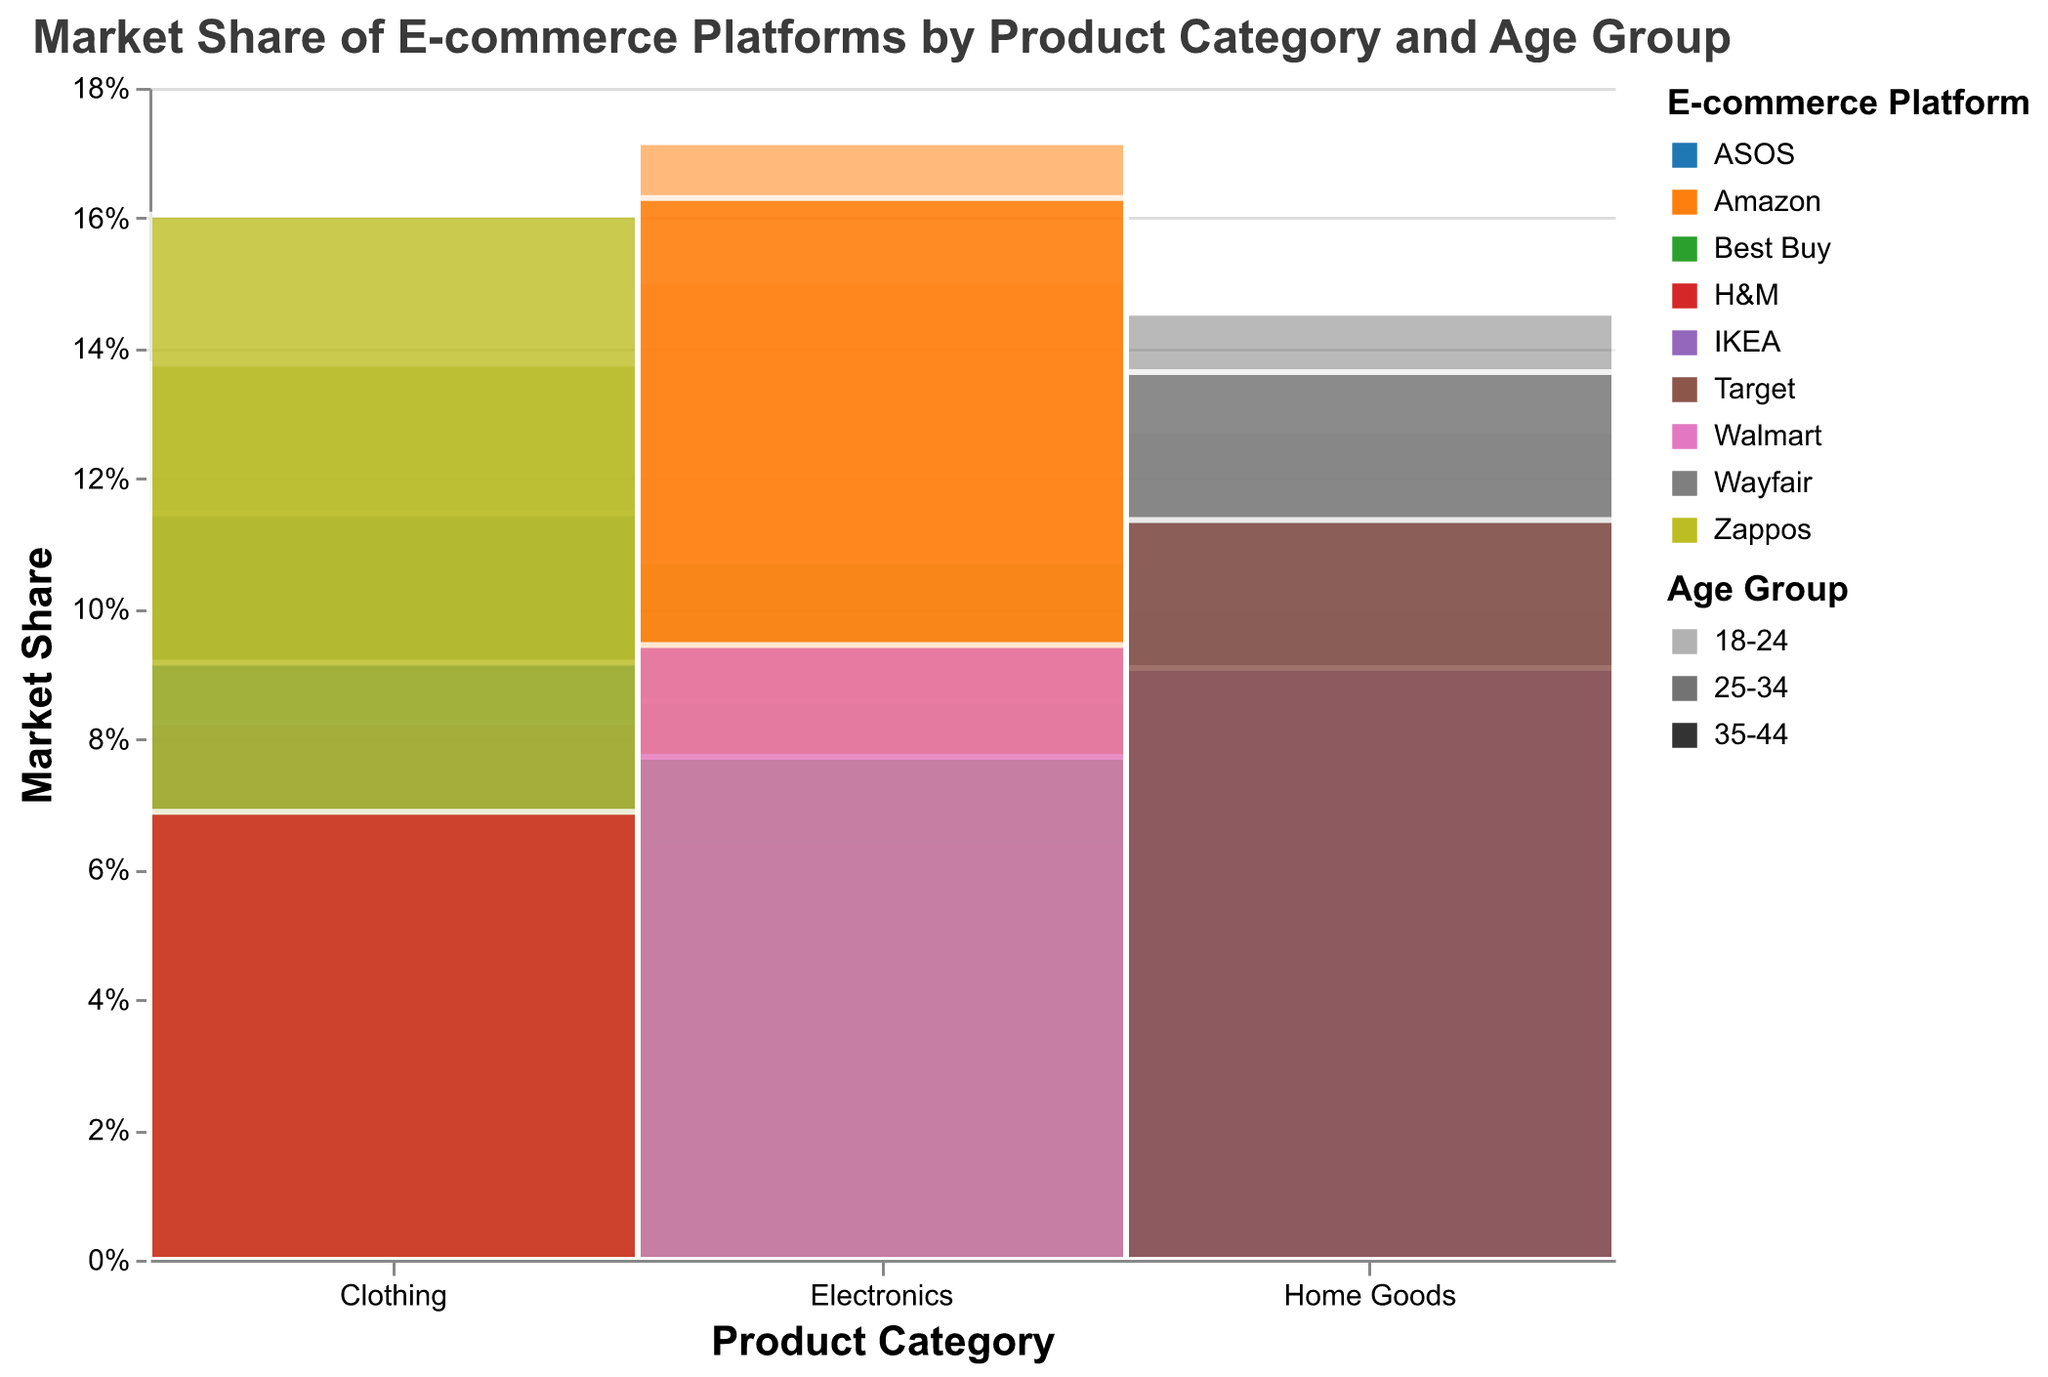What is the title of the figure? The title is the text displayed at the top of the figure indicating what it's about. In this case, it can be found at the center.
Answer: Market Share of E-commerce Platforms by Product Category and Age Group Which e-commerce platform has the highest market share for Electronics in the age group 25-34? To find this, look at the section for Electronics and then focus on the 25-34 age group. The color representing Amazon is the tallest bar in this section.
Answer: Amazon How does the market share of Wayfair for Home Goods compare between the 18-24 and 25-34 age groups? In the Home Goods category, compare the height of the rectangles for Wayfair (color) for both age groups 18-24 and 25-34. Wayfair has a market share of 28 for the 18-24 age group and 32 for the 25-34 age group. Wayfair has a higher market share in the 25-34 age group.
Answer: Wayfair has a higher market share in the 25-34 age group What is the total market share percentage of Best Buy in the Electronics category? Add up the market shares of Best Buy for all age groups in the Electronics category. (25 + 20 + 18) Add this sum and then divide by the sum of the total market share of all platforms in the Electronics category. It involves multiple steps by adding market shares first and then the percentage calculation.
Answer: 20.3% Which platform has the lowest market share for Clothing in the 35-44 age group? In the Clothing category for the 35-44 age group, find the smallest bar. The bar color corresponding to H&M is the smallest.
Answer: H&M In the Home Goods category, which age group has the largest market share for IKEA? Look at the rectangles for IKEA (color coded) in the Home Goods category and compare their sizes across age groups 18-24, 25-34, and 35-44. The largest rectangle for IKEA is in the 25-34 age group.
Answer: 25-34 What product category does Amazon dominate in terms of market share for the 35-44 age group? Look at the product categories and ages where Amazon's color (typically dark) has the largest market share rectangle. For the 35-44 age group, Amazon's largest presence is in the Electronics category.
Answer: Electronics Considering all the platforms, which age group has the highest overall market share in the Clothing category? Sum the market shares for all platforms within each age group in the Clothing category and compare. The highest sum indicates the age group with the highest overall market share. The 35-44 age group has the highest overall market share in the Clothing category.
Answer: 35-44 